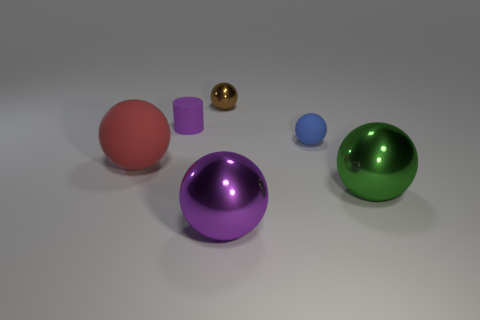There is a sphere on the right side of the tiny blue matte thing; what material is it?
Your answer should be compact. Metal. Do the purple metal thing and the large object that is on the left side of the small shiny ball have the same shape?
Make the answer very short. Yes. Is the number of small brown spheres greater than the number of rubber things?
Offer a terse response. No. Are there any other things that are the same color as the small metallic sphere?
Give a very brief answer. No. The brown thing that is the same material as the big purple thing is what shape?
Provide a succinct answer. Sphere. What is the big object that is to the left of the metal ball that is behind the large red matte sphere made of?
Your response must be concise. Rubber. There is a purple object that is behind the big red matte ball; is it the same shape as the green thing?
Ensure brevity in your answer.  No. Is the number of red objects right of the purple shiny thing greater than the number of large purple metal blocks?
Keep it short and to the point. No. Is there anything else that is the same material as the red sphere?
Provide a short and direct response. Yes. What number of cubes are big green things or large purple objects?
Keep it short and to the point. 0. 